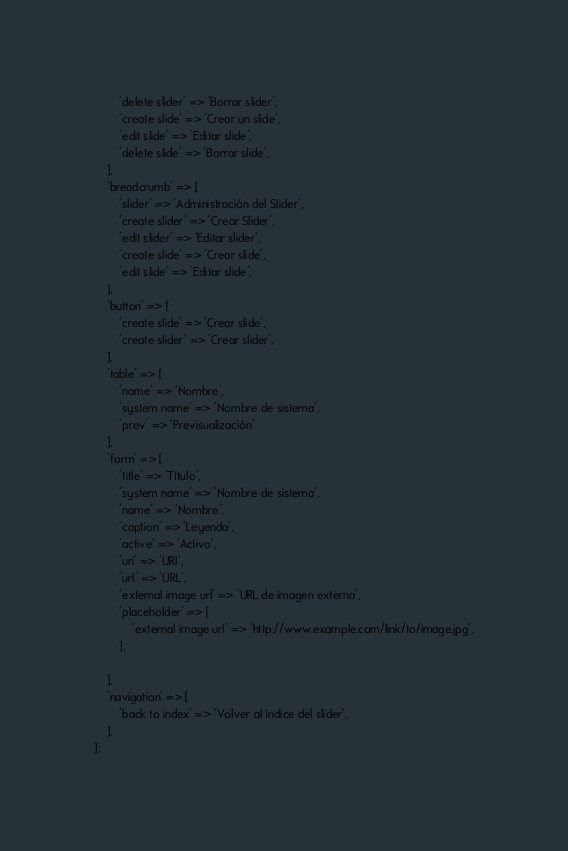<code> <loc_0><loc_0><loc_500><loc_500><_PHP_>        'delete slider' => 'Borrar slider',
        'create slide' => 'Crear un slide',
        'edit slide' => 'Editar slide',
        'delete slide' => 'Borrar slide',
    ],
    'breadcrumb' => [
        'slider' => 'Administración del Slider',
        'create slider' => 'Crear Slider',
        'edit slider' => 'Editar slider',
        'create slide' => 'Crear slide',
        'edit slide' => 'Editar slide',
    ],
    'button' => [
        'create slide' => 'Crear slide',
        'create slider' => 'Crear slider',
    ],
    'table' => [
        'name' => 'Nombre',
        'system name' => 'Nombre de sistema',
        'prev' => 'Previsualización'
    ],
    'form' => [
        'title' => 'Título',
        'system name' => 'Nombre de sistema',
        'name' => 'Nombre',
        'caption' => 'Leyenda',
        'active' => 'Activo',
        'uri' => 'URI',
        'url' => 'URL',
        'external image url' => 'URL de imagen externa',
        'placeholder' => [
            'external image url' => 'http://www.example.com/link/to/image.jpg',
        ],

    ],
    'navigation' => [
        'back to index' => 'Volver al índice del slider',
    ],
];
</code> 